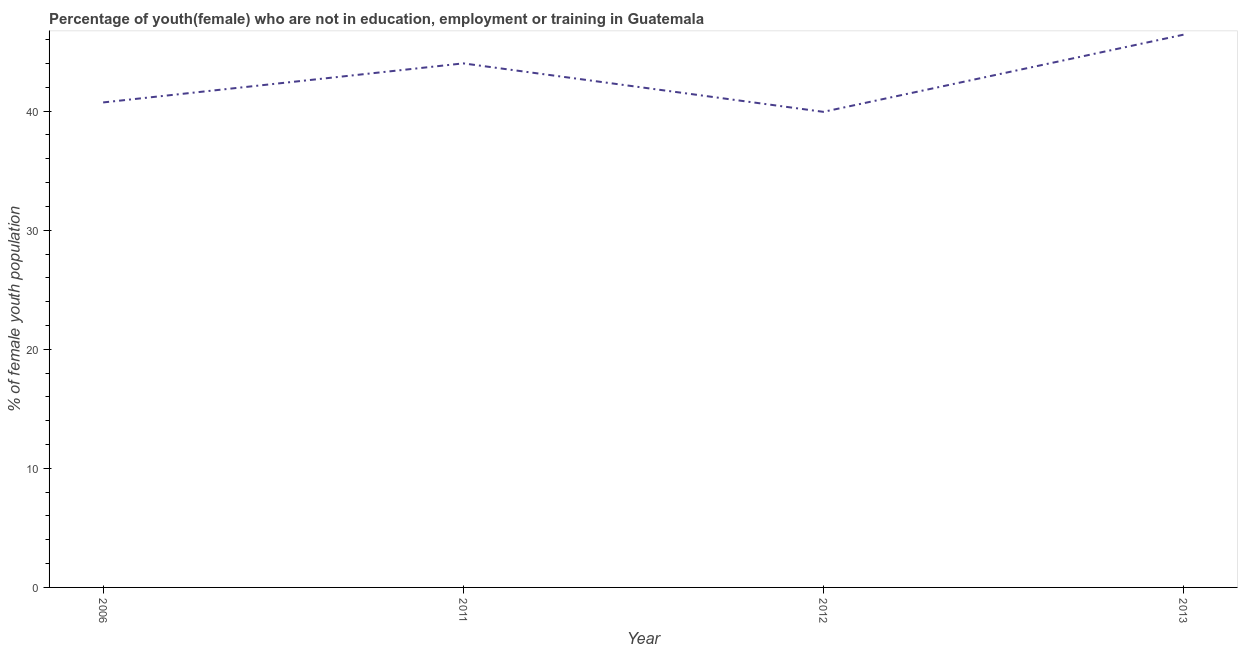What is the unemployed female youth population in 2013?
Give a very brief answer. 46.42. Across all years, what is the maximum unemployed female youth population?
Your response must be concise. 46.42. Across all years, what is the minimum unemployed female youth population?
Your response must be concise. 39.94. In which year was the unemployed female youth population maximum?
Your response must be concise. 2013. In which year was the unemployed female youth population minimum?
Offer a very short reply. 2012. What is the sum of the unemployed female youth population?
Make the answer very short. 171.1. What is the difference between the unemployed female youth population in 2011 and 2013?
Provide a succinct answer. -2.41. What is the average unemployed female youth population per year?
Offer a very short reply. 42.77. What is the median unemployed female youth population?
Your response must be concise. 42.37. What is the ratio of the unemployed female youth population in 2012 to that in 2013?
Provide a succinct answer. 0.86. Is the unemployed female youth population in 2006 less than that in 2012?
Your answer should be compact. No. What is the difference between the highest and the second highest unemployed female youth population?
Provide a short and direct response. 2.41. Is the sum of the unemployed female youth population in 2011 and 2012 greater than the maximum unemployed female youth population across all years?
Provide a succinct answer. Yes. What is the difference between the highest and the lowest unemployed female youth population?
Make the answer very short. 6.48. In how many years, is the unemployed female youth population greater than the average unemployed female youth population taken over all years?
Keep it short and to the point. 2. Does the unemployed female youth population monotonically increase over the years?
Your answer should be very brief. No. How many years are there in the graph?
Offer a terse response. 4. Are the values on the major ticks of Y-axis written in scientific E-notation?
Make the answer very short. No. Does the graph contain any zero values?
Provide a short and direct response. No. Does the graph contain grids?
Offer a terse response. No. What is the title of the graph?
Keep it short and to the point. Percentage of youth(female) who are not in education, employment or training in Guatemala. What is the label or title of the X-axis?
Make the answer very short. Year. What is the label or title of the Y-axis?
Provide a succinct answer. % of female youth population. What is the % of female youth population of 2006?
Give a very brief answer. 40.73. What is the % of female youth population in 2011?
Keep it short and to the point. 44.01. What is the % of female youth population in 2012?
Ensure brevity in your answer.  39.94. What is the % of female youth population in 2013?
Ensure brevity in your answer.  46.42. What is the difference between the % of female youth population in 2006 and 2011?
Keep it short and to the point. -3.28. What is the difference between the % of female youth population in 2006 and 2012?
Provide a short and direct response. 0.79. What is the difference between the % of female youth population in 2006 and 2013?
Offer a very short reply. -5.69. What is the difference between the % of female youth population in 2011 and 2012?
Your response must be concise. 4.07. What is the difference between the % of female youth population in 2011 and 2013?
Provide a short and direct response. -2.41. What is the difference between the % of female youth population in 2012 and 2013?
Your response must be concise. -6.48. What is the ratio of the % of female youth population in 2006 to that in 2011?
Offer a very short reply. 0.93. What is the ratio of the % of female youth population in 2006 to that in 2012?
Your response must be concise. 1.02. What is the ratio of the % of female youth population in 2006 to that in 2013?
Your answer should be very brief. 0.88. What is the ratio of the % of female youth population in 2011 to that in 2012?
Keep it short and to the point. 1.1. What is the ratio of the % of female youth population in 2011 to that in 2013?
Your response must be concise. 0.95. What is the ratio of the % of female youth population in 2012 to that in 2013?
Your answer should be compact. 0.86. 